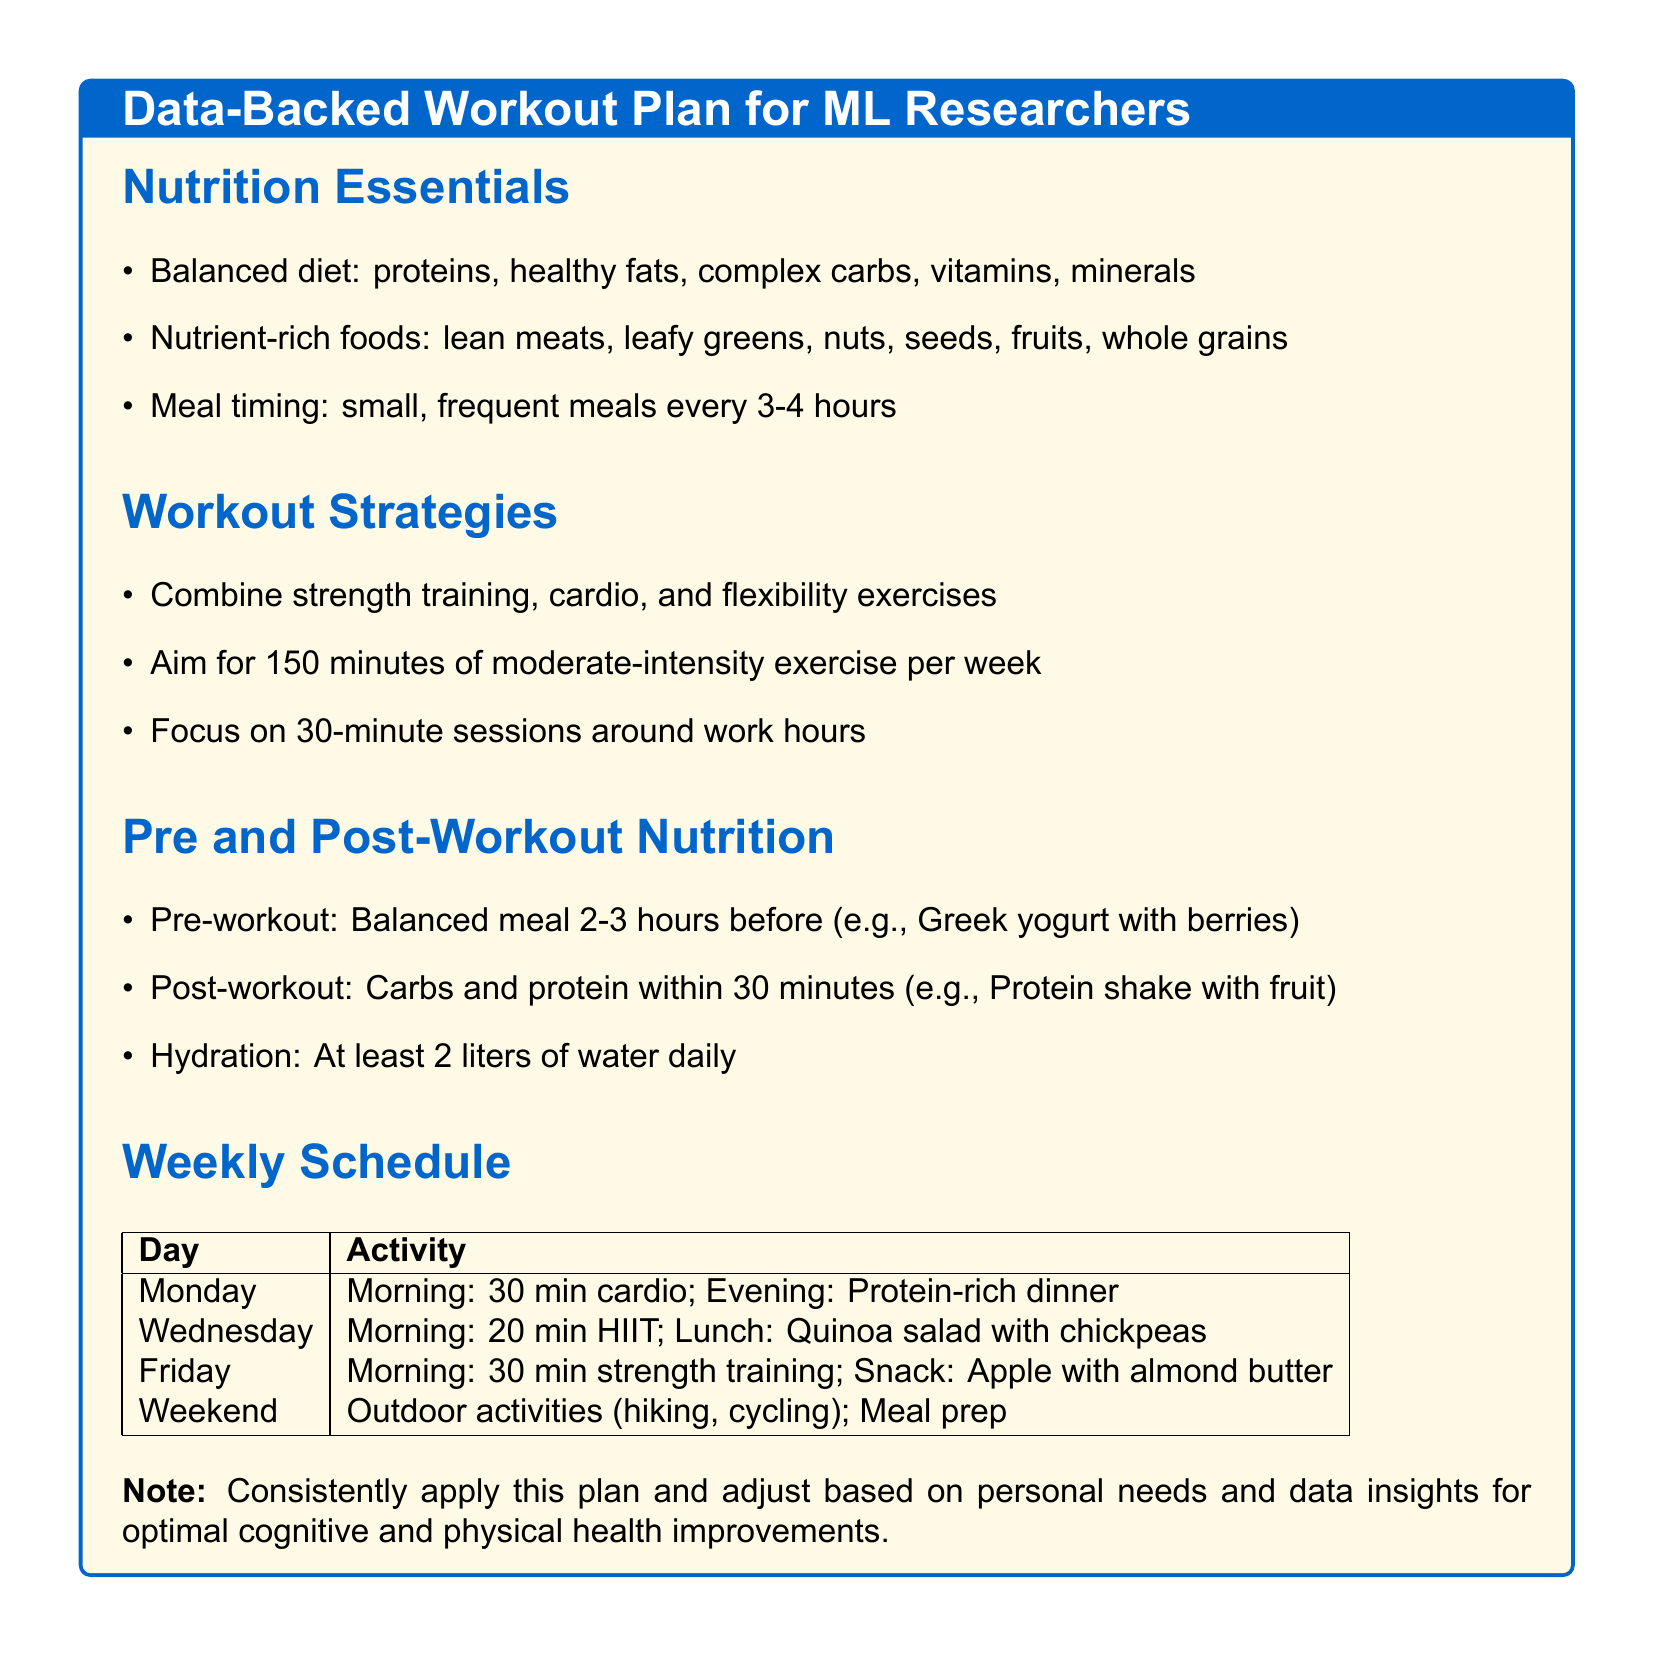What are the three main components of a balanced diet? The document lists the components as proteins, healthy fats, and complex carbs.
Answer: proteins, healthy fats, complex carbs How many minutes of moderate-intensity exercise is recommended per week? The document states the recommendation is 150 minutes of moderate-intensity exercise per week.
Answer: 150 minutes What is scheduled on Monday and Friday mornings in the workout plan? The Monday activity is 30 minutes of cardio and the Friday activity is 30 minutes of strength training.
Answer: 30 min cardio; 30 min strength training What type of meal should be eaten 2-3 hours before a workout? The document suggests a balanced meal like Greek yogurt with berries before a workout.
Answer: Greek yogurt with berries What hydration goal is set in the document? The document specifies a hydration goal of at least 2 liters of water daily.
Answer: 2 liters What is the suggested post-workout nutrition timeframe? It is recommended to consume carbs and protein within 30 minutes after a workout.
Answer: 30 minutes What key strategy combines different types of exercises? The document emphasizes combining strength training, cardio, and flexibility exercises.
Answer: Combine strength training, cardio, and flexibility On which days is meal prep recommended? The weekend is designated for outdoor activities and meal prep according to the document.
Answer: Weekend 